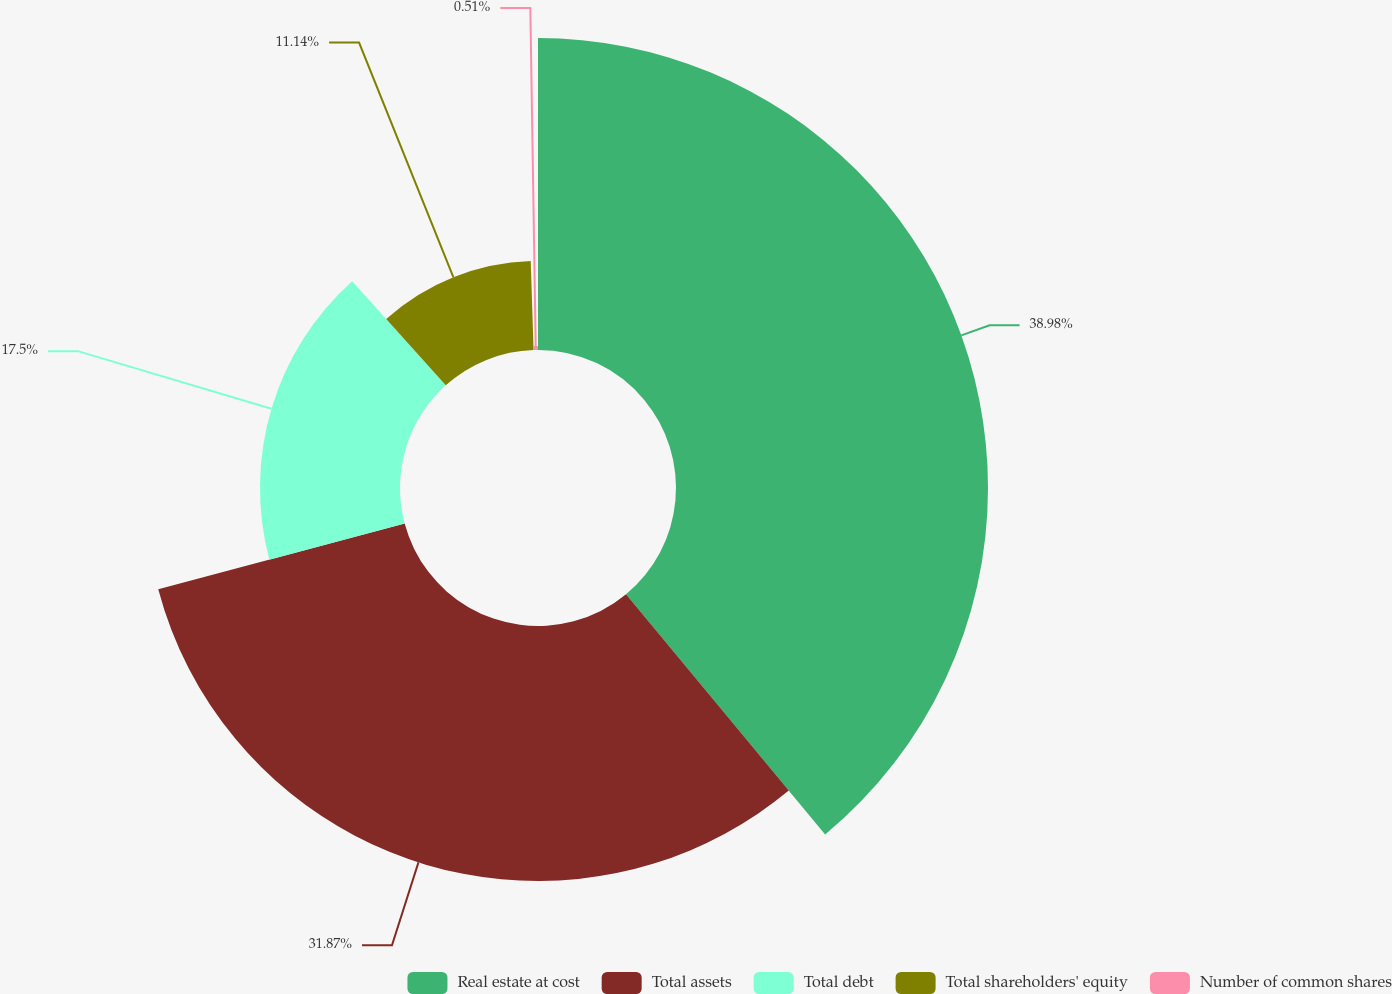<chart> <loc_0><loc_0><loc_500><loc_500><pie_chart><fcel>Real estate at cost<fcel>Total assets<fcel>Total debt<fcel>Total shareholders' equity<fcel>Number of common shares<nl><fcel>38.99%<fcel>31.87%<fcel>17.5%<fcel>11.14%<fcel>0.51%<nl></chart> 